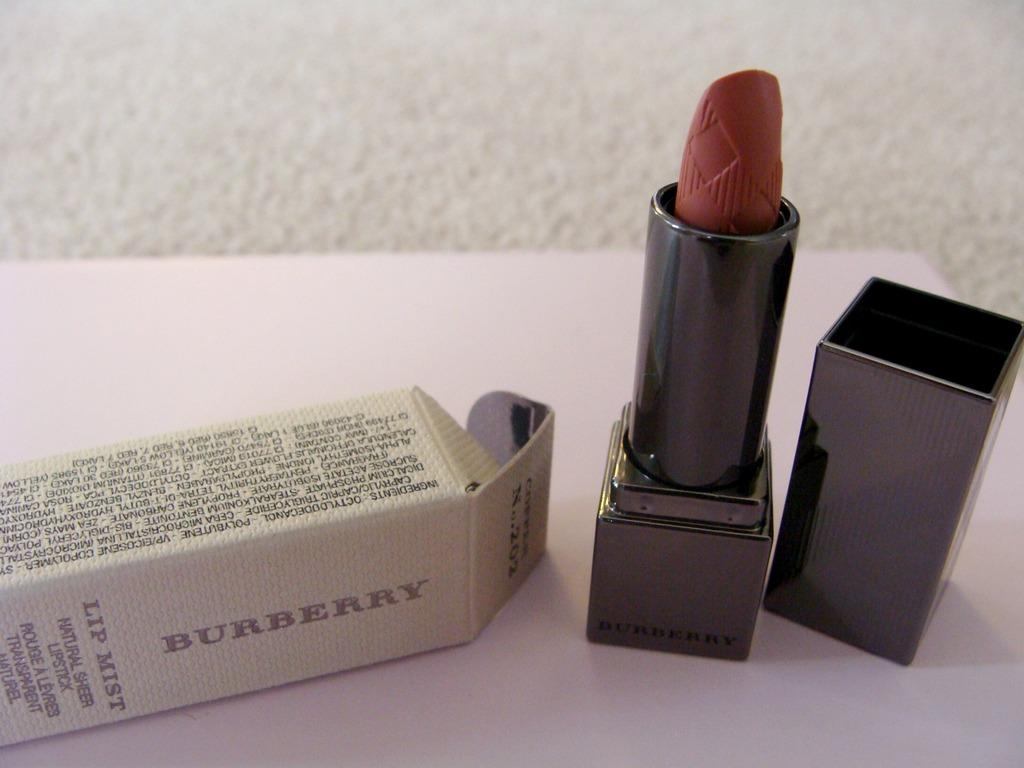<image>
Share a concise interpretation of the image provided. a white box that says 'burberry' next to a stick of lipstick 